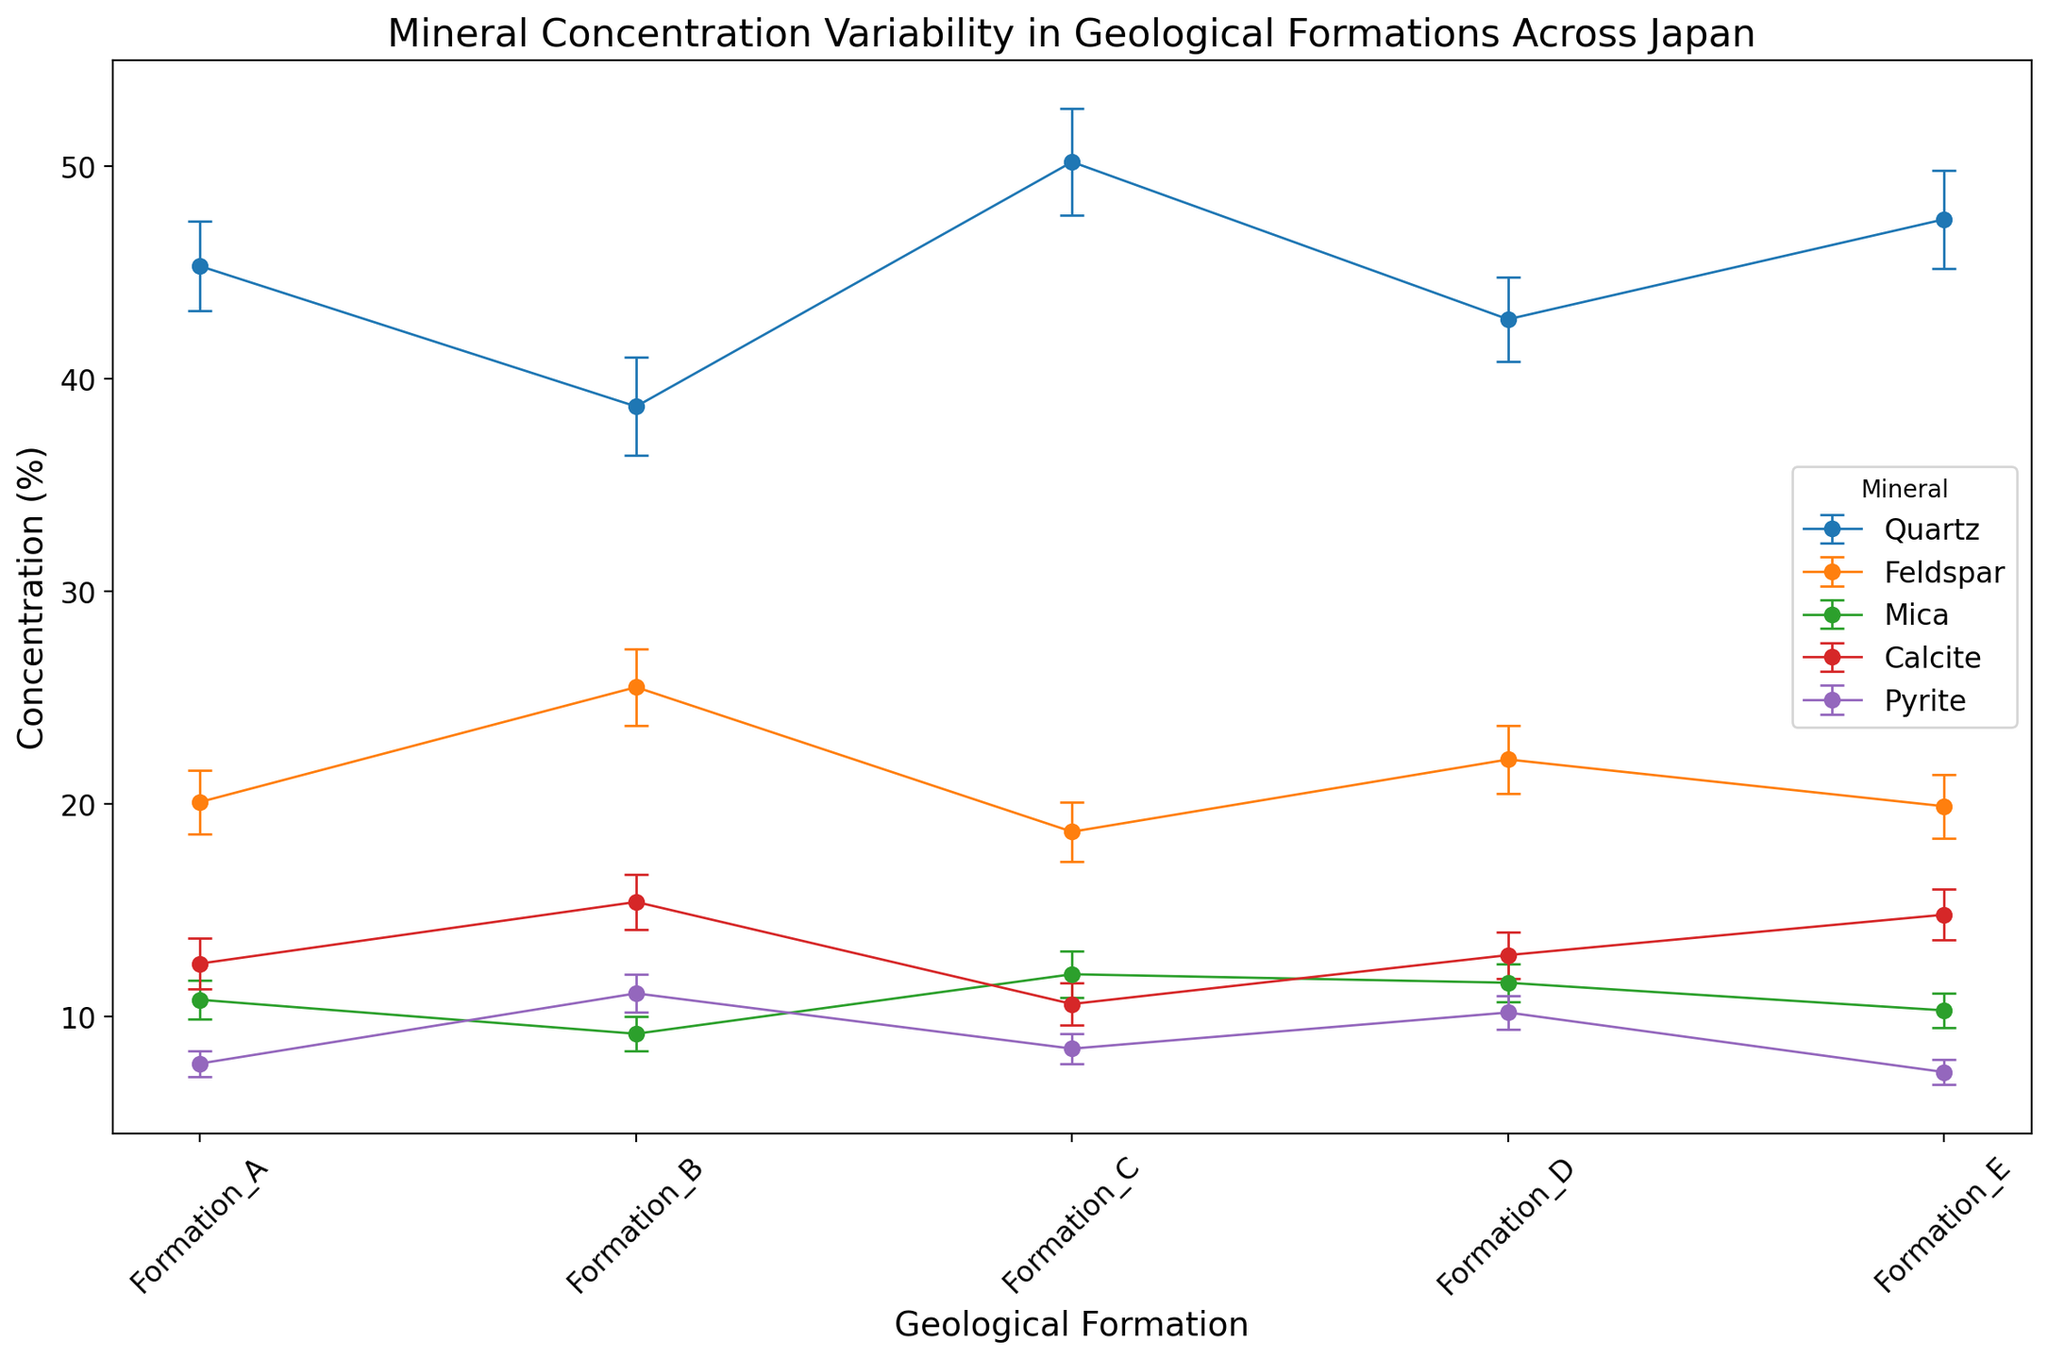What is the concentration and standard error of Quartz in Formation_C? Look at the data point for Quartz in Formation_C; the concentration value of Quartz is represented by the height of the data point, and the error bars show the standard error.
Answer: 50.2 (±2.5) Which formation has the highest concentration of Feldspar? Compare the heights of the data points for Feldspar across all formations; Formation_B has the highest concentration value.
Answer: Formation_B Calculate the average concentration of Calcite across all formations. Sum the concentration values of Calcite in all formations: 12.5 + 15.4 + 10.6 + 12.9 + 14.8 = 66.2. Then, divide by the number of formations (5): 66.2 / 5 = 13.24.
Answer: 13.24 Compare the concentration variability of Pyrite between Formation_A and Formation_E. Which one is greater? Look at the error bars for Pyrite in both Formation_A and Formation_E. The length of the error bars for Formation_A is 0.6, and for Formation_E, it is also 0.6. Therefore, the variability is equal.
Answer: Equal variability What is the difference in the concentration of Quartz between Formation_A and Formation_B? Subtract the concentration value of Quartz in Formation_B from that in Formation_A: 45.3 - 38.7 = 6.6.
Answer: 6.6 Is the concentration of Mica in Formation_D higher or lower than in Formation_C? Compare the heights of the data points for Mica in Formation_D and Formation_C. Formation_D has a concentration of 11.6, and Formation_C has a concentration of 12.0. Thus, Formation_D is lower.
Answer: Lower Between which formations does Feldspar show the maximum standard error, and what is the value? Examine the length of the error bars for Feldspar in all formations. The error bars for Formation_B are the longest at 1.8.
Answer: Formation_B, 1.8 What is the total concentration of Mica in Formation_A and Formation_B combined? Add the concentration values of Mica in Formation_A and Formation_B: 10.8 + 9.2 = 20.0.
Answer: 20.0 Compare the average concentration of Quartz and Calcite across all formations. Which one is higher, and by how much? Sum the concentration values of Quartz and Calcite separately across all formations and then calculate the averages. Quartz: (45.3 + 38.7 + 50.2 + 42.8 + 47.5) / 5 = 44.9. Calcite: (12.5 + 15.4 + 10.6 + 12.9 + 14.8) / 5 = 13.24. The average concentration of Quartz is higher: 44.9 - 13.24 = 31.66.
Answer: Quartz, 31.66 Identify the formation with the lowest concentration of Pyrite and state its concentration and standard error. Compare the heights of the data points for Pyrite across all formations; Formation_E has the lowest concentration with a value of 7.4 and a standard error of 0.6.
Answer: Formation_E, 7.4 (±0.6) 